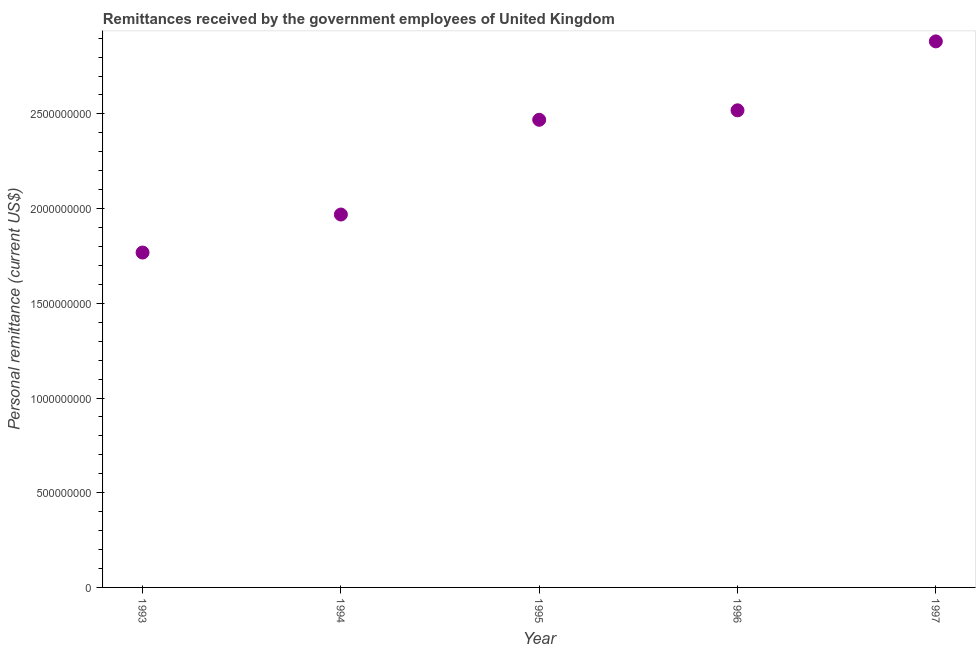What is the personal remittances in 1995?
Ensure brevity in your answer.  2.47e+09. Across all years, what is the maximum personal remittances?
Your answer should be very brief. 2.88e+09. Across all years, what is the minimum personal remittances?
Your response must be concise. 1.77e+09. In which year was the personal remittances maximum?
Provide a short and direct response. 1997. In which year was the personal remittances minimum?
Offer a terse response. 1993. What is the sum of the personal remittances?
Your answer should be compact. 1.16e+1. What is the difference between the personal remittances in 1993 and 1996?
Ensure brevity in your answer.  -7.51e+08. What is the average personal remittances per year?
Provide a short and direct response. 2.32e+09. What is the median personal remittances?
Offer a very short reply. 2.47e+09. In how many years, is the personal remittances greater than 2200000000 US$?
Your response must be concise. 3. What is the ratio of the personal remittances in 1993 to that in 1994?
Offer a very short reply. 0.9. What is the difference between the highest and the second highest personal remittances?
Give a very brief answer. 3.64e+08. What is the difference between the highest and the lowest personal remittances?
Your answer should be very brief. 1.11e+09. What is the difference between two consecutive major ticks on the Y-axis?
Offer a very short reply. 5.00e+08. Does the graph contain grids?
Ensure brevity in your answer.  No. What is the title of the graph?
Offer a terse response. Remittances received by the government employees of United Kingdom. What is the label or title of the X-axis?
Offer a terse response. Year. What is the label or title of the Y-axis?
Give a very brief answer. Personal remittance (current US$). What is the Personal remittance (current US$) in 1993?
Offer a very short reply. 1.77e+09. What is the Personal remittance (current US$) in 1994?
Offer a terse response. 1.97e+09. What is the Personal remittance (current US$) in 1995?
Your answer should be compact. 2.47e+09. What is the Personal remittance (current US$) in 1996?
Provide a succinct answer. 2.52e+09. What is the Personal remittance (current US$) in 1997?
Give a very brief answer. 2.88e+09. What is the difference between the Personal remittance (current US$) in 1993 and 1994?
Give a very brief answer. -2.01e+08. What is the difference between the Personal remittance (current US$) in 1993 and 1995?
Ensure brevity in your answer.  -7.01e+08. What is the difference between the Personal remittance (current US$) in 1993 and 1996?
Keep it short and to the point. -7.51e+08. What is the difference between the Personal remittance (current US$) in 1993 and 1997?
Your answer should be compact. -1.11e+09. What is the difference between the Personal remittance (current US$) in 1994 and 1995?
Your answer should be very brief. -5.00e+08. What is the difference between the Personal remittance (current US$) in 1994 and 1996?
Your answer should be compact. -5.50e+08. What is the difference between the Personal remittance (current US$) in 1994 and 1997?
Provide a short and direct response. -9.14e+08. What is the difference between the Personal remittance (current US$) in 1995 and 1996?
Your answer should be very brief. -5.00e+07. What is the difference between the Personal remittance (current US$) in 1995 and 1997?
Offer a terse response. -4.14e+08. What is the difference between the Personal remittance (current US$) in 1996 and 1997?
Ensure brevity in your answer.  -3.64e+08. What is the ratio of the Personal remittance (current US$) in 1993 to that in 1994?
Make the answer very short. 0.9. What is the ratio of the Personal remittance (current US$) in 1993 to that in 1995?
Provide a short and direct response. 0.72. What is the ratio of the Personal remittance (current US$) in 1993 to that in 1996?
Provide a succinct answer. 0.7. What is the ratio of the Personal remittance (current US$) in 1993 to that in 1997?
Provide a short and direct response. 0.61. What is the ratio of the Personal remittance (current US$) in 1994 to that in 1995?
Provide a short and direct response. 0.8. What is the ratio of the Personal remittance (current US$) in 1994 to that in 1996?
Your answer should be very brief. 0.78. What is the ratio of the Personal remittance (current US$) in 1994 to that in 1997?
Provide a succinct answer. 0.68. What is the ratio of the Personal remittance (current US$) in 1995 to that in 1997?
Make the answer very short. 0.86. What is the ratio of the Personal remittance (current US$) in 1996 to that in 1997?
Provide a succinct answer. 0.87. 